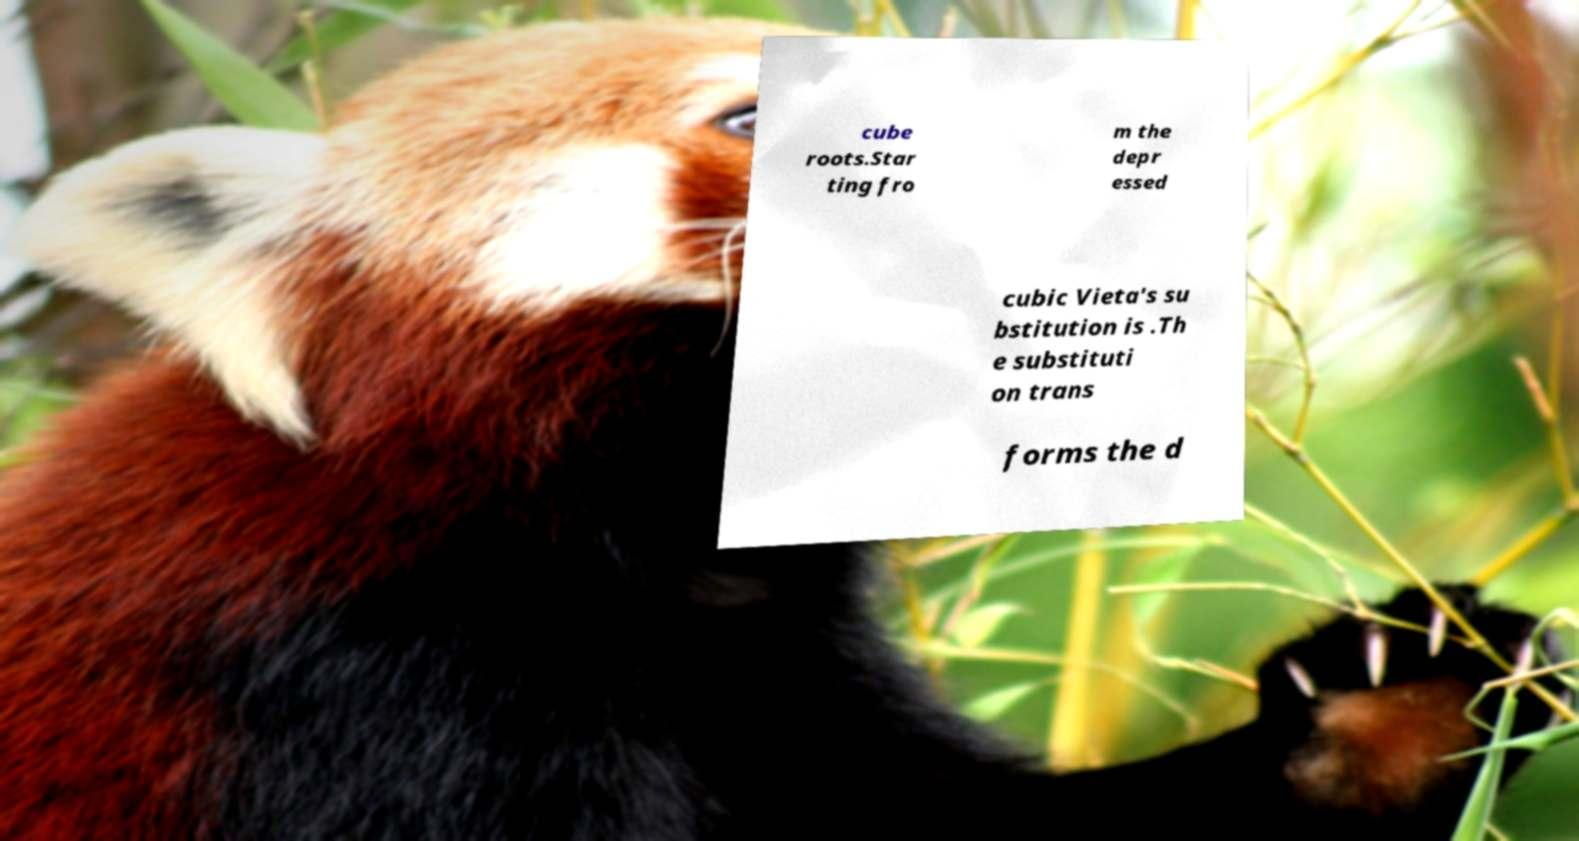I need the written content from this picture converted into text. Can you do that? cube roots.Star ting fro m the depr essed cubic Vieta's su bstitution is .Th e substituti on trans forms the d 